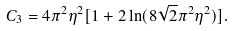<formula> <loc_0><loc_0><loc_500><loc_500>C _ { 3 } = 4 \pi ^ { 2 } \eta ^ { 2 } [ 1 + 2 \ln ( 8 \sqrt { 2 } \pi ^ { 2 } \eta ^ { 2 } ) ] .</formula> 